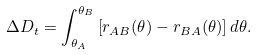<formula> <loc_0><loc_0><loc_500><loc_500>\Delta D _ { t } = \int _ { \theta _ { A } } ^ { \theta _ { B } } \left [ r _ { A B } ( \theta ) - r _ { B A } ( \theta ) \right ] d \theta .</formula> 